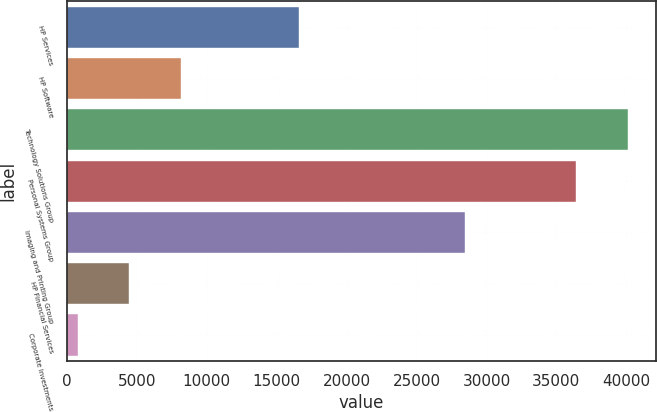<chart> <loc_0><loc_0><loc_500><loc_500><bar_chart><fcel>HP Services<fcel>HP Software<fcel>Technology Solutions Group<fcel>Personal Systems Group<fcel>Imaging and Printing Group<fcel>HP Financial Services<fcel>Corporate Investments<nl><fcel>16570<fcel>8157.6<fcel>40106.8<fcel>36409<fcel>28465<fcel>4459.8<fcel>762<nl></chart> 